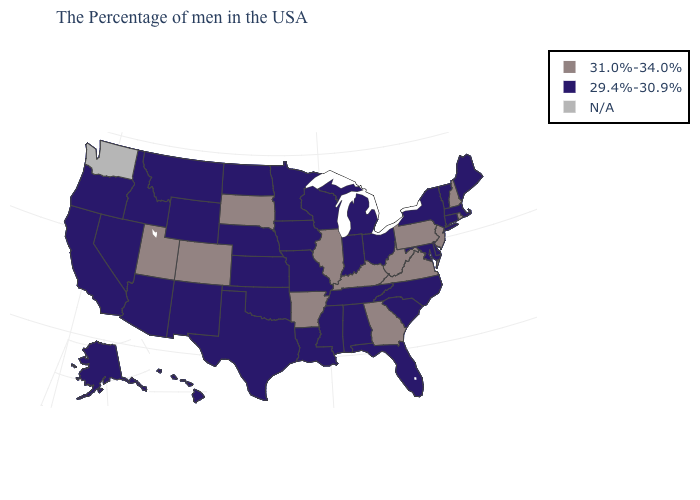Does the first symbol in the legend represent the smallest category?
Keep it brief. No. How many symbols are there in the legend?
Write a very short answer. 3. What is the value of Nevada?
Quick response, please. 29.4%-30.9%. Name the states that have a value in the range 29.4%-30.9%?
Give a very brief answer. Maine, Massachusetts, Vermont, Connecticut, New York, Delaware, Maryland, North Carolina, South Carolina, Ohio, Florida, Michigan, Indiana, Alabama, Tennessee, Wisconsin, Mississippi, Louisiana, Missouri, Minnesota, Iowa, Kansas, Nebraska, Oklahoma, Texas, North Dakota, Wyoming, New Mexico, Montana, Arizona, Idaho, Nevada, California, Oregon, Alaska, Hawaii. Among the states that border Indiana , does Kentucky have the highest value?
Concise answer only. Yes. What is the value of Iowa?
Short answer required. 29.4%-30.9%. Does Connecticut have the highest value in the Northeast?
Concise answer only. No. What is the value of Utah?
Quick response, please. 31.0%-34.0%. What is the lowest value in the USA?
Answer briefly. 29.4%-30.9%. What is the value of Mississippi?
Quick response, please. 29.4%-30.9%. How many symbols are there in the legend?
Be succinct. 3. What is the highest value in the West ?
Quick response, please. 31.0%-34.0%. What is the value of Arizona?
Keep it brief. 29.4%-30.9%. Does the map have missing data?
Give a very brief answer. Yes. Among the states that border Texas , does Arkansas have the highest value?
Give a very brief answer. Yes. 